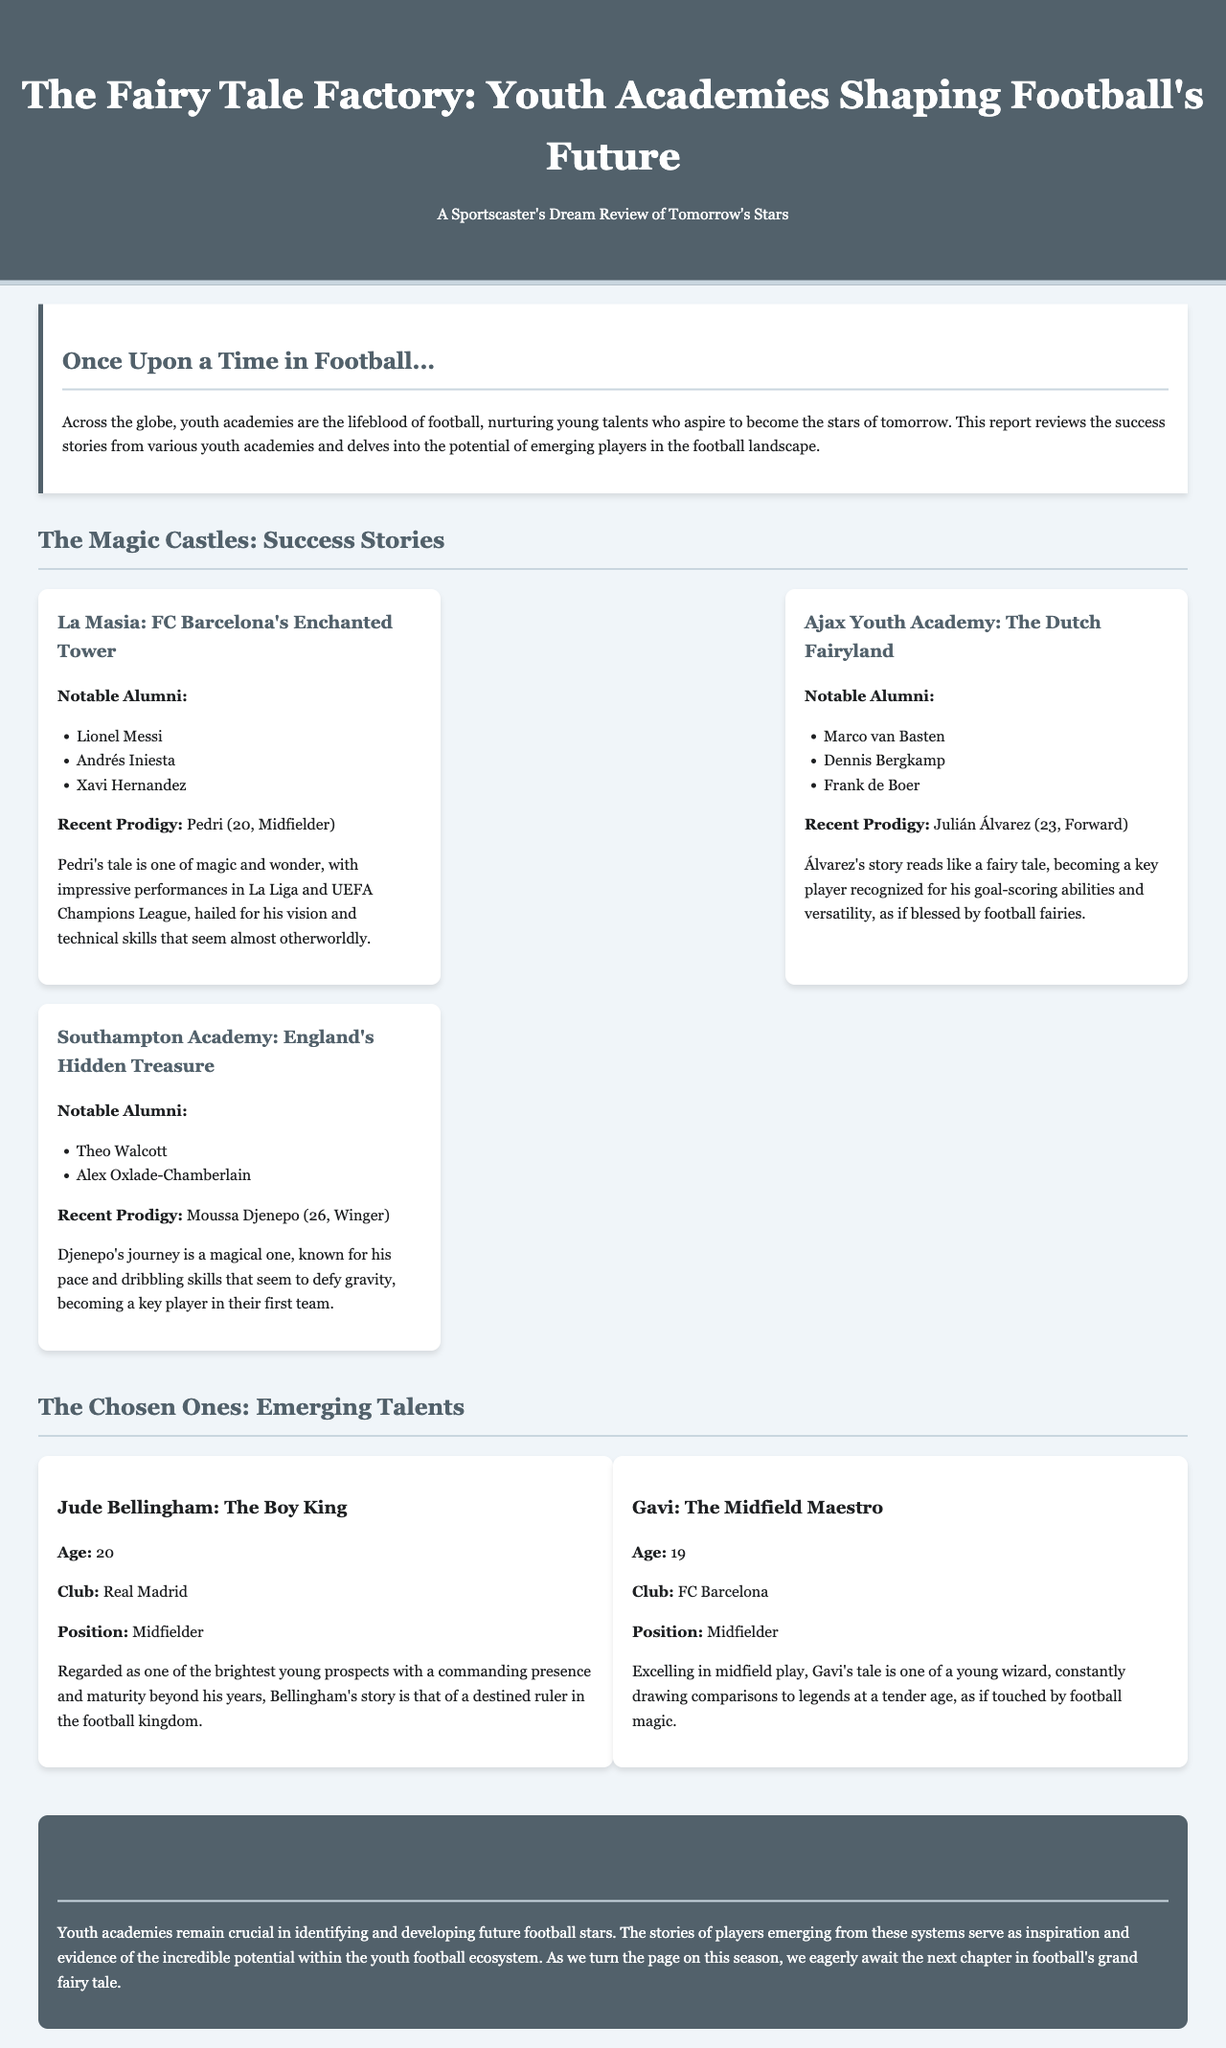What is the title of the report? The title of the report is prominently displayed at the top of the document, introducing the theme of youth academies and their impact on football.
Answer: The Fairy Tale Factory: Youth Academies Shaping Football's Future Who is a notable alumni from La Masia? The document lists several notable alumni from La Masia, one of which is widely recognized as one of the best players in football history.
Answer: Lionel Messi What position does Julián Álvarez play? The recent prodigy from Ajax Youth Academy is identified by his position in the team, highlighting his importance and skills.
Answer: Forward How old is Jude Bellingham? The report explicitly mentions the age of this young talent, showcasing his youth and potential in the sport.
Answer: 20 What academy is known as England's Hidden Treasure? The report categorizes different youth academies, and one of them is specifically noted for its significance in England.
Answer: Southampton Academy What is Moussa Djenepo known for? The report describes Moussa Djenepo's attributes, emphasizing a unique skill that sets him apart as a player.
Answer: Pace and dribbling skills Which two young talents are highlighted as "The Chosen Ones"? The report references two emerging stars in football, capturing their narratives and rising status in the game.
Answer: Jude Bellingham and Gavi What is the overarching theme of the document? The introduction provides insight into the main focus of the report, which revolves around youth development in football.
Answer: Youth academies nurturing young talents 